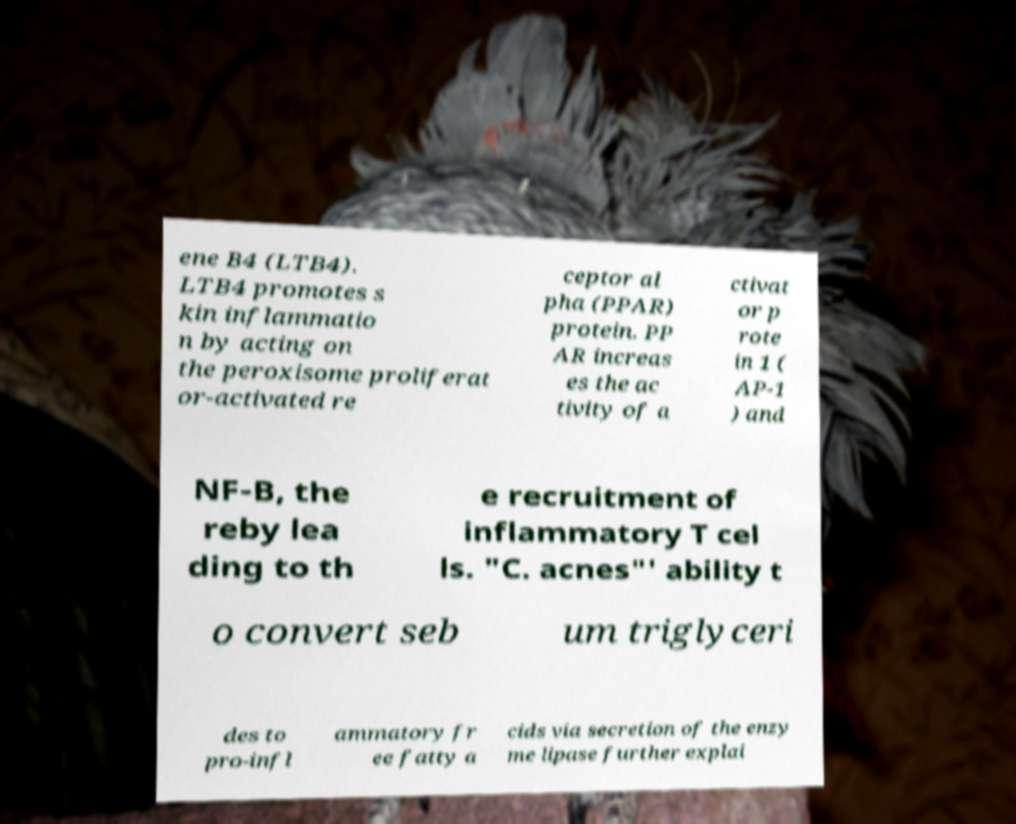Can you accurately transcribe the text from the provided image for me? ene B4 (LTB4). LTB4 promotes s kin inflammatio n by acting on the peroxisome proliferat or-activated re ceptor al pha (PPAR) protein. PP AR increas es the ac tivity of a ctivat or p rote in 1 ( AP-1 ) and NF-B, the reby lea ding to th e recruitment of inflammatory T cel ls. "C. acnes"' ability t o convert seb um triglyceri des to pro-infl ammatory fr ee fatty a cids via secretion of the enzy me lipase further explai 